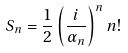<formula> <loc_0><loc_0><loc_500><loc_500>S _ { n } = \frac { 1 } { 2 } \left ( \frac { i } { \alpha _ { n } } \right ) ^ { n } n !</formula> 